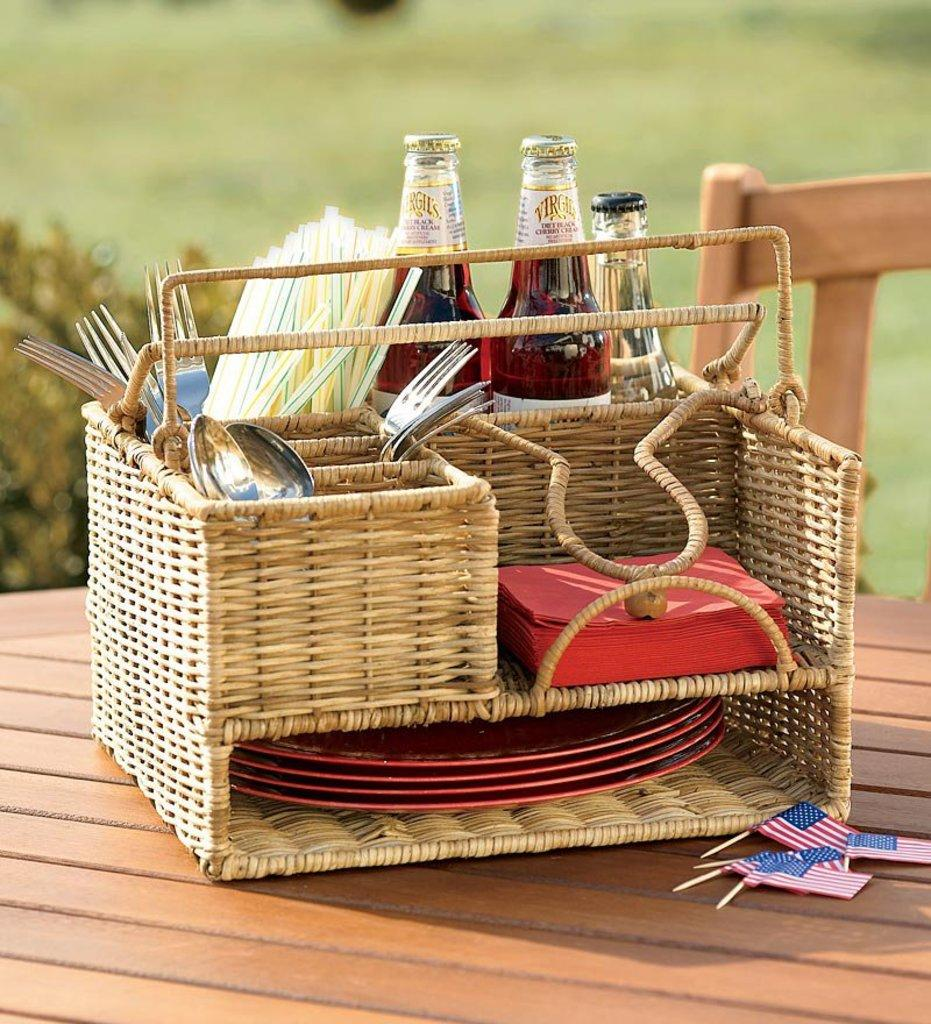What types of utensils are visible in the image? There are spoons and forks in the image. What color are the napkins in the image? The napkins in the image are red. What can be used for drinking in the image? There are straws in the image for drinking. What type of dishware is present in the image? There are plates in the image. What type of containers are present in the image? There are glass bottles in the image. How are the objects arranged in the image? The objects are placed in a wooden basket. What can be said about the background of the image? The background of the image is blurred. How many waves can be seen in the image? There are no waves present in the image. 